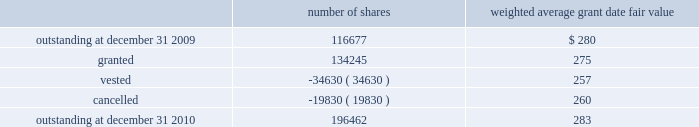The company granted 1020 performance shares .
The vesting of these shares is contingent on meeting stated goals over a performance period .
Beginning with restricted stock grants in september 2010 , dividends are accrued on restricted class a common stock and restricted stock units and are paid once the restricted stock vests .
The table summarizes restricted stock and performance shares activity for 2010 : number of shares weighted average grant date fair value .
The total fair value of restricted stock that vested during the years ended december 31 , 2010 , 2009 and 2008 , was $ 10.3 million , $ 6.2 million and $ 2.5 million , respectively .
Eligible employees may acquire shares of cme group 2019s class a common stock using after-tax payroll deductions made during consecutive offering periods of approximately six months in duration .
Shares are purchased at the end of each offering period at a price of 90% ( 90 % ) of the closing price of the class a common stock as reported on the nasdaq .
Compensation expense is recognized on the dates of purchase for the discount from the closing price .
In 2010 , 2009 and 2008 , a total of 4371 , 4402 and 5600 shares , respectively , of class a common stock were issued to participating employees .
These shares are subject to a six-month holding period .
Annual expense of $ 0.1 million for the purchase discount was recognized in 2010 , 2009 and 2008 , respectively .
Non-executive directors receive an annual award of class a common stock with a value equal to $ 75000 .
Non-executive directors may also elect to receive some or all of the cash portion of their annual stipend , up to $ 25000 , in shares of stock based on the closing price at the date of distribution .
As a result , 7470 , 11674 and 5509 shares of class a common stock were issued to non-executive directors during 2010 , 2009 and 2008 , respectively .
These shares are not subject to any vesting restrictions .
Expense of $ 2.4 million , $ 2.5 million and $ 2.4 million related to these stock-based payments was recognized for the years ended december 31 , 2010 , 2009 and 2008 , respectively. .
What was the sum of the total fair value of restricted stock that vested during 2008 and 2010 in millions? 
Computations: ((10.3 + 6.2) + 2.5)
Answer: 19.0. The company granted 1020 performance shares .
The vesting of these shares is contingent on meeting stated goals over a performance period .
Beginning with restricted stock grants in september 2010 , dividends are accrued on restricted class a common stock and restricted stock units and are paid once the restricted stock vests .
The table summarizes restricted stock and performance shares activity for 2010 : number of shares weighted average grant date fair value .
The total fair value of restricted stock that vested during the years ended december 31 , 2010 , 2009 and 2008 , was $ 10.3 million , $ 6.2 million and $ 2.5 million , respectively .
Eligible employees may acquire shares of cme group 2019s class a common stock using after-tax payroll deductions made during consecutive offering periods of approximately six months in duration .
Shares are purchased at the end of each offering period at a price of 90% ( 90 % ) of the closing price of the class a common stock as reported on the nasdaq .
Compensation expense is recognized on the dates of purchase for the discount from the closing price .
In 2010 , 2009 and 2008 , a total of 4371 , 4402 and 5600 shares , respectively , of class a common stock were issued to participating employees .
These shares are subject to a six-month holding period .
Annual expense of $ 0.1 million for the purchase discount was recognized in 2010 , 2009 and 2008 , respectively .
Non-executive directors receive an annual award of class a common stock with a value equal to $ 75000 .
Non-executive directors may also elect to receive some or all of the cash portion of their annual stipend , up to $ 25000 , in shares of stock based on the closing price at the date of distribution .
As a result , 7470 , 11674 and 5509 shares of class a common stock were issued to non-executive directors during 2010 , 2009 and 2008 , respectively .
These shares are not subject to any vesting restrictions .
Expense of $ 2.4 million , $ 2.5 million and $ 2.4 million related to these stock-based payments was recognized for the years ended december 31 , 2010 , 2009 and 2008 , respectively. .
Considering the weighted average grant date fair value , whats is the difference between how many actual shares vested during the year of 2010 and how many vested based on the average grant fair value? 
Rationale: its the total fair value of restricted stocks that vested in 2010 divided by the average grant fair value and compared with the actual number of vested shares .
Computations: (((10.3 * 1000000) / 257) - 34630)
Answer: 5447.82101. 